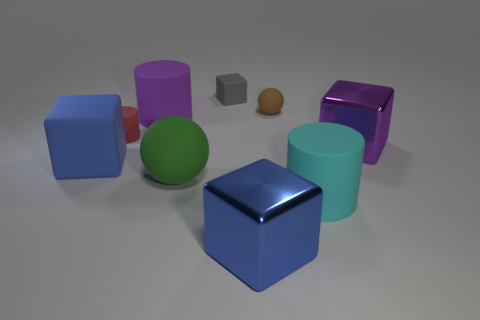What number of objects are the same color as the big ball?
Your answer should be very brief. 0. There is a big blue object that is to the right of the big blue object behind the large green object; what is its shape?
Your answer should be very brief. Cube. Are there the same number of big blue matte balls and big purple things?
Provide a succinct answer. No. How many large green spheres have the same material as the big purple block?
Ensure brevity in your answer.  0. What is the material of the large purple object that is on the left side of the purple block?
Your answer should be very brief. Rubber. The large metal thing that is in front of the metallic thing that is to the right of the big cylinder to the right of the gray thing is what shape?
Provide a short and direct response. Cube. There is a large matte block left of the big cyan object; does it have the same color as the matte sphere that is in front of the small red rubber cylinder?
Ensure brevity in your answer.  No. Are there fewer small brown rubber objects behind the small gray rubber thing than purple blocks left of the large purple cube?
Offer a terse response. No. Are there any other things that have the same shape as the cyan object?
Provide a short and direct response. Yes. What is the color of the tiny matte object that is the same shape as the large green object?
Make the answer very short. Brown. 